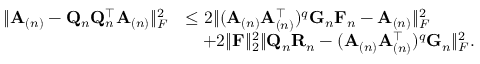Convert formula to latex. <formula><loc_0><loc_0><loc_500><loc_500>\begin{array} { r l } { \| A _ { ( n ) } - Q _ { n } Q _ { n } ^ { \top } A _ { ( n ) } \| _ { F } ^ { 2 } } & { \leq 2 \| ( A _ { ( n ) } A _ { ( n ) } ^ { \top } ) ^ { q } G _ { n } F _ { n } - A _ { ( n ) } \| _ { F } ^ { 2 } } \\ & { \quad + 2 \| F \| _ { 2 } ^ { 2 } \| Q _ { n } R _ { n } - ( A _ { ( n ) } A _ { ( n ) } ^ { \top } ) ^ { q } G _ { n } \| _ { F } ^ { 2 } . } \end{array}</formula> 